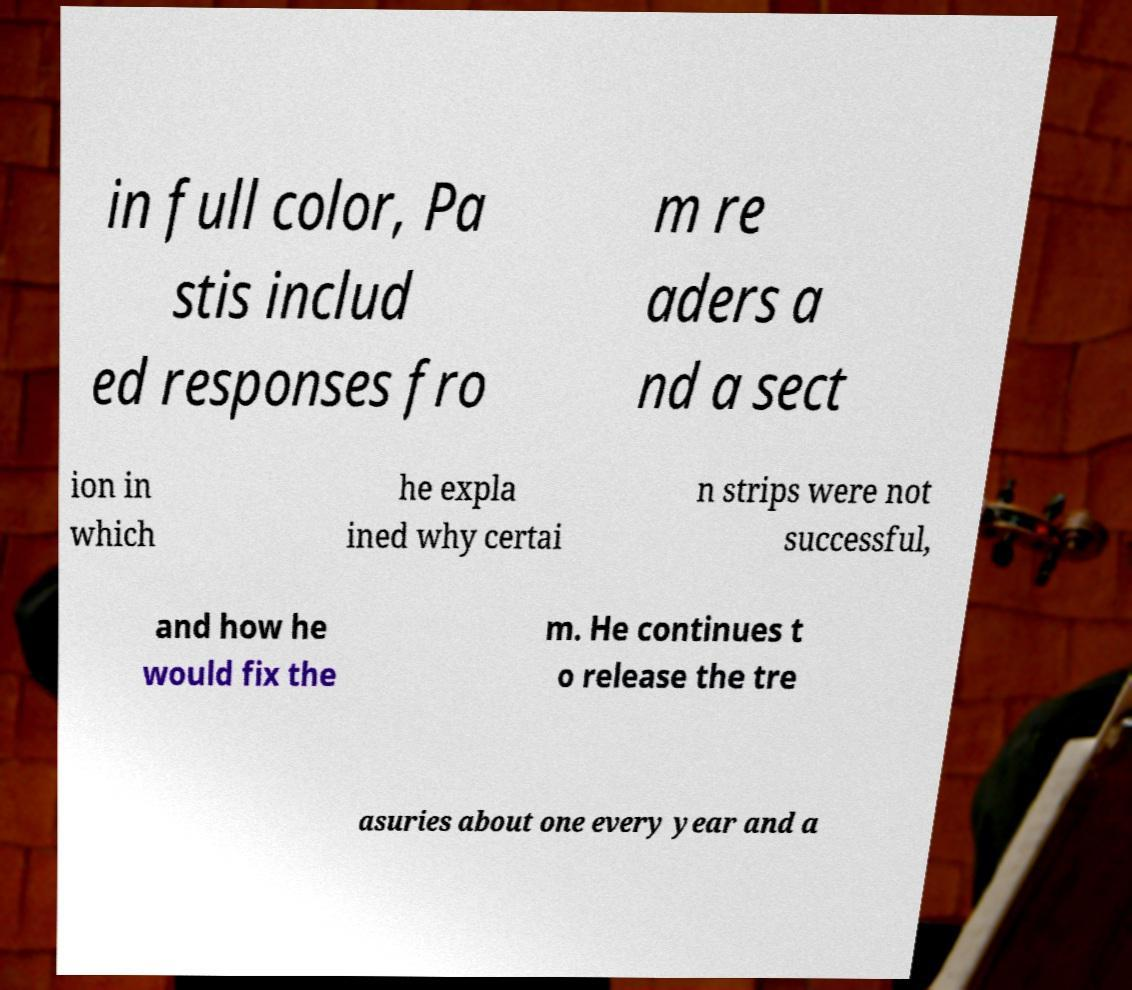I need the written content from this picture converted into text. Can you do that? in full color, Pa stis includ ed responses fro m re aders a nd a sect ion in which he expla ined why certai n strips were not successful, and how he would fix the m. He continues t o release the tre asuries about one every year and a 